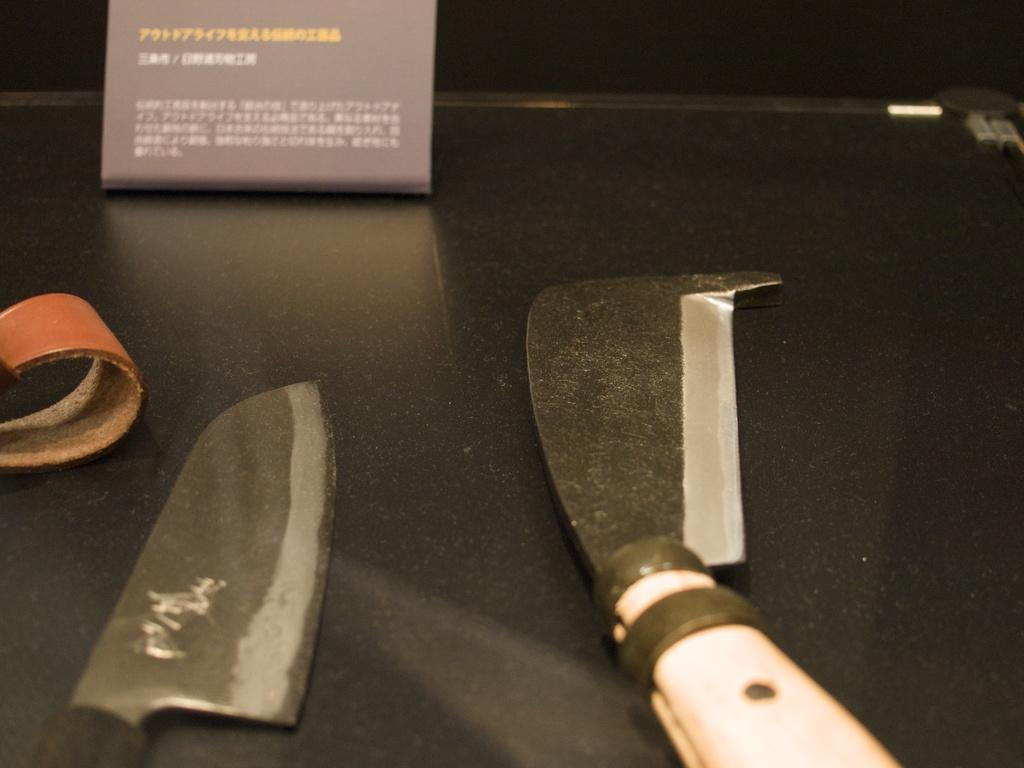What is the color of the surface in the image? The surface in the image is black colored. What objects can be seen on the surface? There are two knives and an orange colored object on the surface. What is the color of the board in the image? The board in the image is black colored. What letters are being taught on the black colored board in the image? There are no letters or any indication of teaching in the image; it only shows a black colored board. What arithmetic problem is being solved on the surface in the image? There are no arithmetic problems or any indication of solving problems in the image; it only shows a black surface with two knives and an orange colored object. 